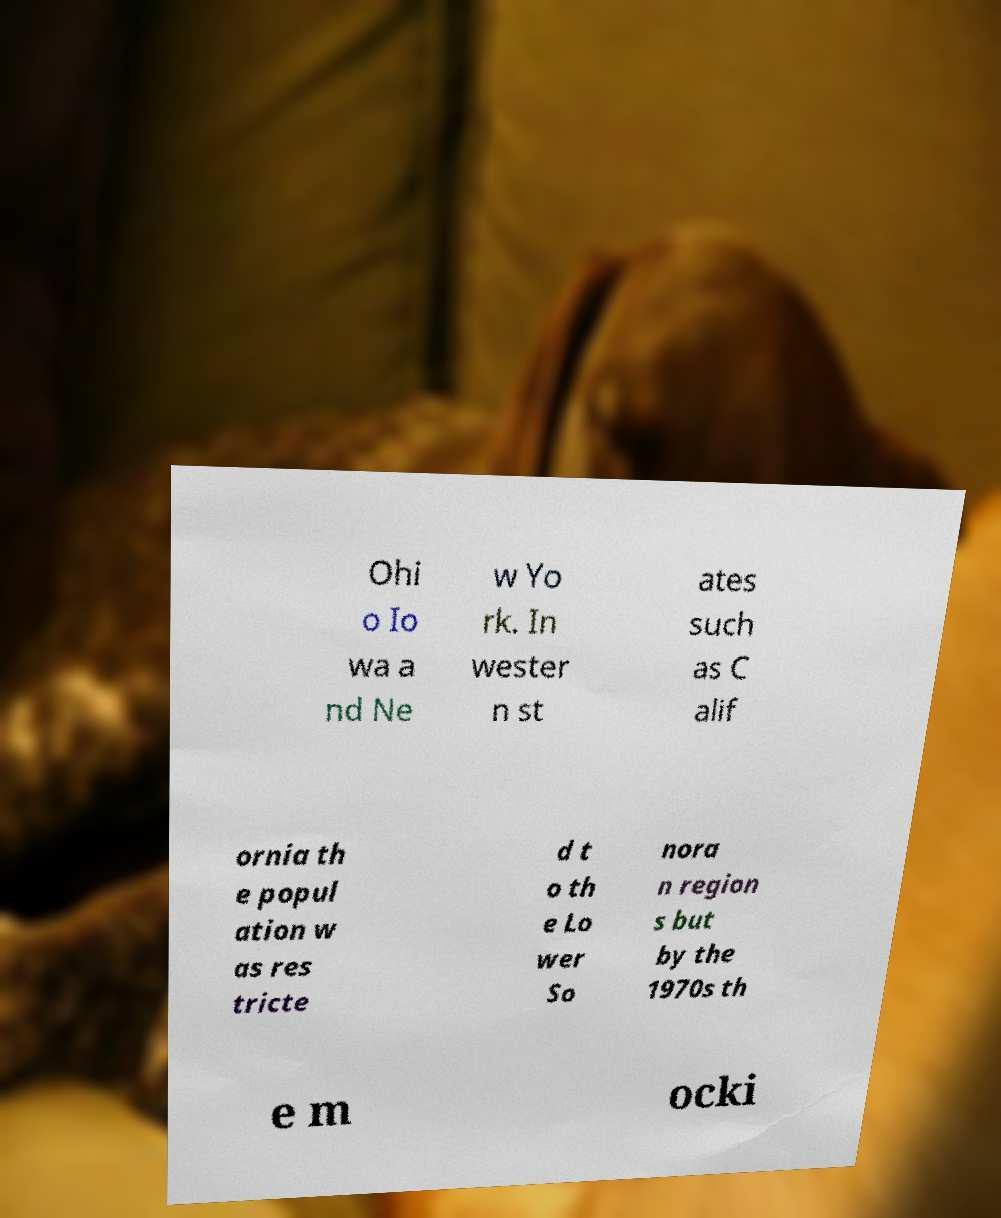Please identify and transcribe the text found in this image. Ohi o Io wa a nd Ne w Yo rk. In wester n st ates such as C alif ornia th e popul ation w as res tricte d t o th e Lo wer So nora n region s but by the 1970s th e m ocki 